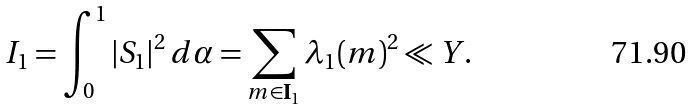Convert formula to latex. <formula><loc_0><loc_0><loc_500><loc_500>I _ { 1 } = \int _ { 0 } ^ { 1 } | S _ { 1 } | ^ { 2 } \, d \alpha = \sum _ { m \in \mathbf I _ { 1 } } \lambda _ { 1 } ( m ) ^ { 2 } \ll Y .</formula> 